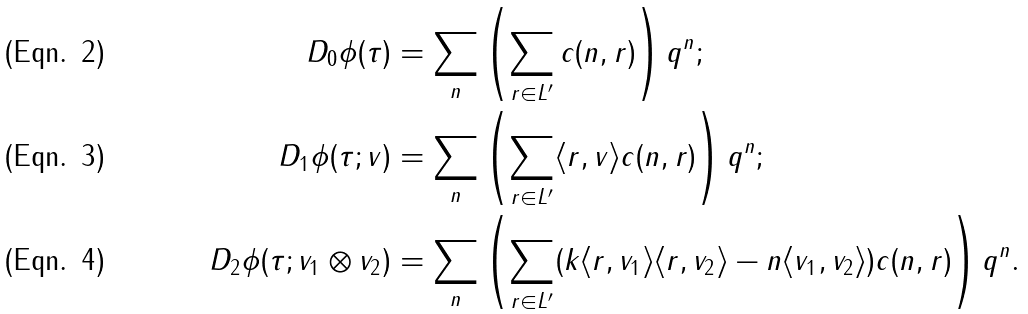<formula> <loc_0><loc_0><loc_500><loc_500>D _ { 0 } \phi ( \tau ) & = \sum _ { n } \left ( \sum _ { r \in L ^ { \prime } } c ( n , r ) \right ) q ^ { n } ; \\ D _ { 1 } \phi ( \tau ; v ) & = \sum _ { n } \left ( \sum _ { r \in L ^ { \prime } } \langle r , v \rangle c ( n , r ) \right ) q ^ { n } ; \\ D _ { 2 } \phi ( \tau ; v _ { 1 } \otimes v _ { 2 } ) & = \sum _ { n } \left ( \sum _ { r \in L ^ { \prime } } ( k \langle r , v _ { 1 } \rangle \langle r , v _ { 2 } \rangle - n \langle v _ { 1 } , v _ { 2 } \rangle ) c ( n , r ) \right ) q ^ { n } .</formula> 